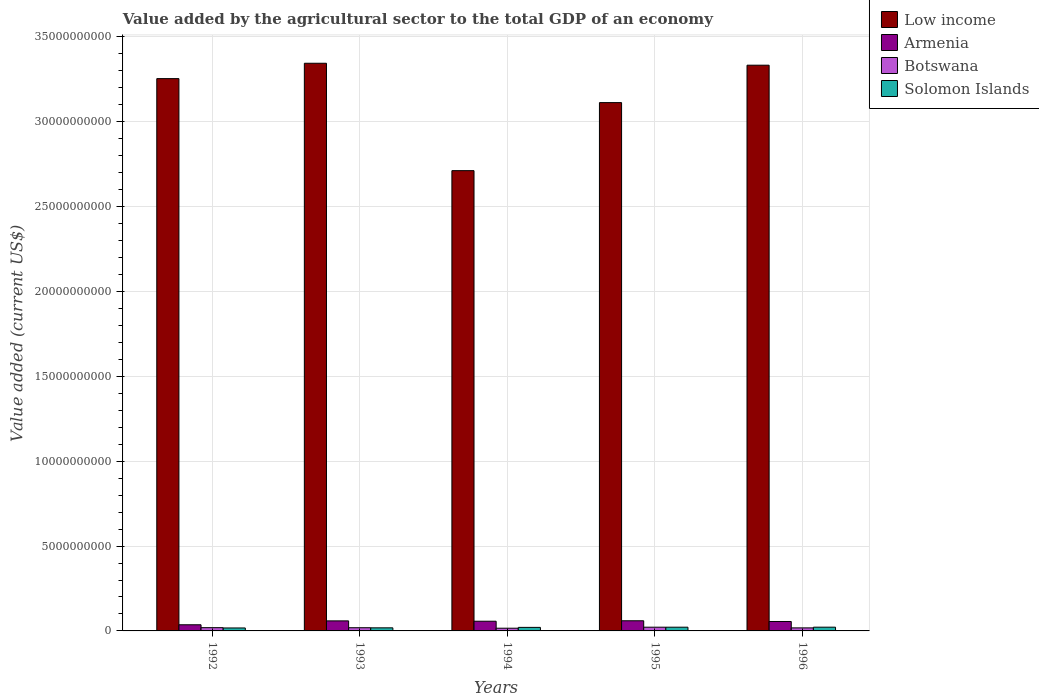How many groups of bars are there?
Make the answer very short. 5. Are the number of bars on each tick of the X-axis equal?
Provide a short and direct response. Yes. What is the label of the 3rd group of bars from the left?
Offer a terse response. 1994. In how many cases, is the number of bars for a given year not equal to the number of legend labels?
Your response must be concise. 0. What is the value added by the agricultural sector to the total GDP in Armenia in 1993?
Offer a terse response. 5.92e+08. Across all years, what is the maximum value added by the agricultural sector to the total GDP in Armenia?
Provide a short and direct response. 5.97e+08. Across all years, what is the minimum value added by the agricultural sector to the total GDP in Armenia?
Give a very brief answer. 3.63e+08. What is the total value added by the agricultural sector to the total GDP in Low income in the graph?
Provide a succinct answer. 1.58e+11. What is the difference between the value added by the agricultural sector to the total GDP in Armenia in 1992 and that in 1996?
Give a very brief answer. -1.93e+08. What is the difference between the value added by the agricultural sector to the total GDP in Solomon Islands in 1992 and the value added by the agricultural sector to the total GDP in Armenia in 1996?
Provide a short and direct response. -3.82e+08. What is the average value added by the agricultural sector to the total GDP in Low income per year?
Provide a succinct answer. 3.15e+1. In the year 1996, what is the difference between the value added by the agricultural sector to the total GDP in Botswana and value added by the agricultural sector to the total GDP in Armenia?
Provide a succinct answer. -3.77e+08. What is the ratio of the value added by the agricultural sector to the total GDP in Low income in 1995 to that in 1996?
Give a very brief answer. 0.93. What is the difference between the highest and the second highest value added by the agricultural sector to the total GDP in Low income?
Provide a succinct answer. 1.14e+08. What is the difference between the highest and the lowest value added by the agricultural sector to the total GDP in Botswana?
Give a very brief answer. 5.94e+07. Is the sum of the value added by the agricultural sector to the total GDP in Low income in 1992 and 1996 greater than the maximum value added by the agricultural sector to the total GDP in Armenia across all years?
Offer a terse response. Yes. What does the 2nd bar from the left in 1994 represents?
Provide a short and direct response. Armenia. What does the 1st bar from the right in 1994 represents?
Ensure brevity in your answer.  Solomon Islands. Are all the bars in the graph horizontal?
Your answer should be compact. No. How many years are there in the graph?
Provide a short and direct response. 5. What is the difference between two consecutive major ticks on the Y-axis?
Offer a terse response. 5.00e+09. Are the values on the major ticks of Y-axis written in scientific E-notation?
Your answer should be very brief. No. How many legend labels are there?
Ensure brevity in your answer.  4. What is the title of the graph?
Make the answer very short. Value added by the agricultural sector to the total GDP of an economy. Does "Honduras" appear as one of the legend labels in the graph?
Make the answer very short. No. What is the label or title of the X-axis?
Keep it short and to the point. Years. What is the label or title of the Y-axis?
Make the answer very short. Value added (current US$). What is the Value added (current US$) of Low income in 1992?
Offer a very short reply. 3.25e+1. What is the Value added (current US$) in Armenia in 1992?
Your answer should be compact. 3.63e+08. What is the Value added (current US$) in Botswana in 1992?
Provide a short and direct response. 1.92e+08. What is the Value added (current US$) of Solomon Islands in 1992?
Provide a succinct answer. 1.74e+08. What is the Value added (current US$) in Low income in 1993?
Make the answer very short. 3.34e+1. What is the Value added (current US$) of Armenia in 1993?
Ensure brevity in your answer.  5.92e+08. What is the Value added (current US$) in Botswana in 1993?
Offer a very short reply. 1.88e+08. What is the Value added (current US$) in Solomon Islands in 1993?
Make the answer very short. 1.82e+08. What is the Value added (current US$) of Low income in 1994?
Provide a short and direct response. 2.71e+1. What is the Value added (current US$) of Armenia in 1994?
Your answer should be very brief. 5.72e+08. What is the Value added (current US$) in Botswana in 1994?
Your response must be concise. 1.60e+08. What is the Value added (current US$) of Solomon Islands in 1994?
Keep it short and to the point. 2.09e+08. What is the Value added (current US$) in Low income in 1995?
Keep it short and to the point. 3.11e+1. What is the Value added (current US$) in Armenia in 1995?
Offer a terse response. 5.97e+08. What is the Value added (current US$) of Botswana in 1995?
Offer a very short reply. 2.19e+08. What is the Value added (current US$) in Solomon Islands in 1995?
Your response must be concise. 2.20e+08. What is the Value added (current US$) in Low income in 1996?
Provide a short and direct response. 3.33e+1. What is the Value added (current US$) of Armenia in 1996?
Offer a terse response. 5.56e+08. What is the Value added (current US$) in Botswana in 1996?
Give a very brief answer. 1.79e+08. What is the Value added (current US$) of Solomon Islands in 1996?
Your response must be concise. 2.21e+08. Across all years, what is the maximum Value added (current US$) of Low income?
Give a very brief answer. 3.34e+1. Across all years, what is the maximum Value added (current US$) in Armenia?
Ensure brevity in your answer.  5.97e+08. Across all years, what is the maximum Value added (current US$) in Botswana?
Your answer should be very brief. 2.19e+08. Across all years, what is the maximum Value added (current US$) of Solomon Islands?
Make the answer very short. 2.21e+08. Across all years, what is the minimum Value added (current US$) in Low income?
Offer a very short reply. 2.71e+1. Across all years, what is the minimum Value added (current US$) in Armenia?
Ensure brevity in your answer.  3.63e+08. Across all years, what is the minimum Value added (current US$) in Botswana?
Your answer should be compact. 1.60e+08. Across all years, what is the minimum Value added (current US$) in Solomon Islands?
Provide a short and direct response. 1.74e+08. What is the total Value added (current US$) of Low income in the graph?
Offer a terse response. 1.58e+11. What is the total Value added (current US$) of Armenia in the graph?
Offer a terse response. 2.68e+09. What is the total Value added (current US$) in Botswana in the graph?
Ensure brevity in your answer.  9.38e+08. What is the total Value added (current US$) of Solomon Islands in the graph?
Give a very brief answer. 1.01e+09. What is the difference between the Value added (current US$) of Low income in 1992 and that in 1993?
Provide a short and direct response. -9.05e+08. What is the difference between the Value added (current US$) in Armenia in 1992 and that in 1993?
Make the answer very short. -2.29e+08. What is the difference between the Value added (current US$) in Botswana in 1992 and that in 1993?
Provide a short and direct response. 4.01e+06. What is the difference between the Value added (current US$) of Solomon Islands in 1992 and that in 1993?
Ensure brevity in your answer.  -8.02e+06. What is the difference between the Value added (current US$) of Low income in 1992 and that in 1994?
Your response must be concise. 5.42e+09. What is the difference between the Value added (current US$) of Armenia in 1992 and that in 1994?
Keep it short and to the point. -2.09e+08. What is the difference between the Value added (current US$) of Botswana in 1992 and that in 1994?
Your answer should be very brief. 3.21e+07. What is the difference between the Value added (current US$) of Solomon Islands in 1992 and that in 1994?
Your answer should be compact. -3.46e+07. What is the difference between the Value added (current US$) of Low income in 1992 and that in 1995?
Give a very brief answer. 1.41e+09. What is the difference between the Value added (current US$) of Armenia in 1992 and that in 1995?
Make the answer very short. -2.35e+08. What is the difference between the Value added (current US$) of Botswana in 1992 and that in 1995?
Give a very brief answer. -2.73e+07. What is the difference between the Value added (current US$) of Solomon Islands in 1992 and that in 1995?
Keep it short and to the point. -4.56e+07. What is the difference between the Value added (current US$) of Low income in 1992 and that in 1996?
Give a very brief answer. -7.91e+08. What is the difference between the Value added (current US$) of Armenia in 1992 and that in 1996?
Ensure brevity in your answer.  -1.93e+08. What is the difference between the Value added (current US$) in Botswana in 1992 and that in 1996?
Your answer should be compact. 1.32e+07. What is the difference between the Value added (current US$) in Solomon Islands in 1992 and that in 1996?
Give a very brief answer. -4.69e+07. What is the difference between the Value added (current US$) in Low income in 1993 and that in 1994?
Your answer should be compact. 6.33e+09. What is the difference between the Value added (current US$) in Armenia in 1993 and that in 1994?
Your answer should be compact. 2.01e+07. What is the difference between the Value added (current US$) of Botswana in 1993 and that in 1994?
Your response must be concise. 2.81e+07. What is the difference between the Value added (current US$) in Solomon Islands in 1993 and that in 1994?
Your answer should be compact. -2.66e+07. What is the difference between the Value added (current US$) of Low income in 1993 and that in 1995?
Your answer should be very brief. 2.32e+09. What is the difference between the Value added (current US$) of Armenia in 1993 and that in 1995?
Make the answer very short. -5.75e+06. What is the difference between the Value added (current US$) in Botswana in 1993 and that in 1995?
Make the answer very short. -3.13e+07. What is the difference between the Value added (current US$) in Solomon Islands in 1993 and that in 1995?
Make the answer very short. -3.76e+07. What is the difference between the Value added (current US$) of Low income in 1993 and that in 1996?
Your response must be concise. 1.14e+08. What is the difference between the Value added (current US$) in Armenia in 1993 and that in 1996?
Ensure brevity in your answer.  3.60e+07. What is the difference between the Value added (current US$) of Botswana in 1993 and that in 1996?
Provide a short and direct response. 9.16e+06. What is the difference between the Value added (current US$) in Solomon Islands in 1993 and that in 1996?
Offer a terse response. -3.89e+07. What is the difference between the Value added (current US$) in Low income in 1994 and that in 1995?
Offer a very short reply. -4.01e+09. What is the difference between the Value added (current US$) of Armenia in 1994 and that in 1995?
Provide a short and direct response. -2.59e+07. What is the difference between the Value added (current US$) of Botswana in 1994 and that in 1995?
Offer a very short reply. -5.94e+07. What is the difference between the Value added (current US$) in Solomon Islands in 1994 and that in 1995?
Keep it short and to the point. -1.10e+07. What is the difference between the Value added (current US$) of Low income in 1994 and that in 1996?
Give a very brief answer. -6.21e+09. What is the difference between the Value added (current US$) of Armenia in 1994 and that in 1996?
Offer a terse response. 1.59e+07. What is the difference between the Value added (current US$) of Botswana in 1994 and that in 1996?
Keep it short and to the point. -1.89e+07. What is the difference between the Value added (current US$) in Solomon Islands in 1994 and that in 1996?
Give a very brief answer. -1.22e+07. What is the difference between the Value added (current US$) of Low income in 1995 and that in 1996?
Your answer should be compact. -2.20e+09. What is the difference between the Value added (current US$) in Armenia in 1995 and that in 1996?
Ensure brevity in your answer.  4.18e+07. What is the difference between the Value added (current US$) of Botswana in 1995 and that in 1996?
Make the answer very short. 4.05e+07. What is the difference between the Value added (current US$) in Solomon Islands in 1995 and that in 1996?
Your answer should be compact. -1.28e+06. What is the difference between the Value added (current US$) in Low income in 1992 and the Value added (current US$) in Armenia in 1993?
Keep it short and to the point. 3.19e+1. What is the difference between the Value added (current US$) of Low income in 1992 and the Value added (current US$) of Botswana in 1993?
Your answer should be compact. 3.24e+1. What is the difference between the Value added (current US$) in Low income in 1992 and the Value added (current US$) in Solomon Islands in 1993?
Offer a terse response. 3.24e+1. What is the difference between the Value added (current US$) in Armenia in 1992 and the Value added (current US$) in Botswana in 1993?
Keep it short and to the point. 1.74e+08. What is the difference between the Value added (current US$) of Armenia in 1992 and the Value added (current US$) of Solomon Islands in 1993?
Make the answer very short. 1.80e+08. What is the difference between the Value added (current US$) of Botswana in 1992 and the Value added (current US$) of Solomon Islands in 1993?
Provide a succinct answer. 1.01e+07. What is the difference between the Value added (current US$) in Low income in 1992 and the Value added (current US$) in Armenia in 1994?
Give a very brief answer. 3.20e+1. What is the difference between the Value added (current US$) of Low income in 1992 and the Value added (current US$) of Botswana in 1994?
Provide a short and direct response. 3.24e+1. What is the difference between the Value added (current US$) in Low income in 1992 and the Value added (current US$) in Solomon Islands in 1994?
Provide a short and direct response. 3.23e+1. What is the difference between the Value added (current US$) of Armenia in 1992 and the Value added (current US$) of Botswana in 1994?
Offer a terse response. 2.03e+08. What is the difference between the Value added (current US$) in Armenia in 1992 and the Value added (current US$) in Solomon Islands in 1994?
Keep it short and to the point. 1.54e+08. What is the difference between the Value added (current US$) of Botswana in 1992 and the Value added (current US$) of Solomon Islands in 1994?
Offer a very short reply. -1.65e+07. What is the difference between the Value added (current US$) of Low income in 1992 and the Value added (current US$) of Armenia in 1995?
Keep it short and to the point. 3.19e+1. What is the difference between the Value added (current US$) of Low income in 1992 and the Value added (current US$) of Botswana in 1995?
Your answer should be compact. 3.23e+1. What is the difference between the Value added (current US$) in Low income in 1992 and the Value added (current US$) in Solomon Islands in 1995?
Give a very brief answer. 3.23e+1. What is the difference between the Value added (current US$) in Armenia in 1992 and the Value added (current US$) in Botswana in 1995?
Your response must be concise. 1.43e+08. What is the difference between the Value added (current US$) of Armenia in 1992 and the Value added (current US$) of Solomon Islands in 1995?
Offer a very short reply. 1.43e+08. What is the difference between the Value added (current US$) of Botswana in 1992 and the Value added (current US$) of Solomon Islands in 1995?
Ensure brevity in your answer.  -2.75e+07. What is the difference between the Value added (current US$) of Low income in 1992 and the Value added (current US$) of Armenia in 1996?
Your answer should be very brief. 3.20e+1. What is the difference between the Value added (current US$) in Low income in 1992 and the Value added (current US$) in Botswana in 1996?
Your answer should be compact. 3.24e+1. What is the difference between the Value added (current US$) of Low income in 1992 and the Value added (current US$) of Solomon Islands in 1996?
Ensure brevity in your answer.  3.23e+1. What is the difference between the Value added (current US$) in Armenia in 1992 and the Value added (current US$) in Botswana in 1996?
Keep it short and to the point. 1.84e+08. What is the difference between the Value added (current US$) of Armenia in 1992 and the Value added (current US$) of Solomon Islands in 1996?
Provide a succinct answer. 1.42e+08. What is the difference between the Value added (current US$) of Botswana in 1992 and the Value added (current US$) of Solomon Islands in 1996?
Provide a succinct answer. -2.88e+07. What is the difference between the Value added (current US$) in Low income in 1993 and the Value added (current US$) in Armenia in 1994?
Ensure brevity in your answer.  3.29e+1. What is the difference between the Value added (current US$) of Low income in 1993 and the Value added (current US$) of Botswana in 1994?
Make the answer very short. 3.33e+1. What is the difference between the Value added (current US$) of Low income in 1993 and the Value added (current US$) of Solomon Islands in 1994?
Provide a succinct answer. 3.32e+1. What is the difference between the Value added (current US$) of Armenia in 1993 and the Value added (current US$) of Botswana in 1994?
Give a very brief answer. 4.32e+08. What is the difference between the Value added (current US$) in Armenia in 1993 and the Value added (current US$) in Solomon Islands in 1994?
Give a very brief answer. 3.83e+08. What is the difference between the Value added (current US$) of Botswana in 1993 and the Value added (current US$) of Solomon Islands in 1994?
Your answer should be very brief. -2.05e+07. What is the difference between the Value added (current US$) of Low income in 1993 and the Value added (current US$) of Armenia in 1995?
Offer a terse response. 3.28e+1. What is the difference between the Value added (current US$) in Low income in 1993 and the Value added (current US$) in Botswana in 1995?
Provide a short and direct response. 3.32e+1. What is the difference between the Value added (current US$) of Low income in 1993 and the Value added (current US$) of Solomon Islands in 1995?
Provide a succinct answer. 3.32e+1. What is the difference between the Value added (current US$) of Armenia in 1993 and the Value added (current US$) of Botswana in 1995?
Your answer should be compact. 3.72e+08. What is the difference between the Value added (current US$) of Armenia in 1993 and the Value added (current US$) of Solomon Islands in 1995?
Give a very brief answer. 3.72e+08. What is the difference between the Value added (current US$) of Botswana in 1993 and the Value added (current US$) of Solomon Islands in 1995?
Your answer should be compact. -3.15e+07. What is the difference between the Value added (current US$) of Low income in 1993 and the Value added (current US$) of Armenia in 1996?
Provide a succinct answer. 3.29e+1. What is the difference between the Value added (current US$) in Low income in 1993 and the Value added (current US$) in Botswana in 1996?
Ensure brevity in your answer.  3.33e+1. What is the difference between the Value added (current US$) in Low income in 1993 and the Value added (current US$) in Solomon Islands in 1996?
Ensure brevity in your answer.  3.32e+1. What is the difference between the Value added (current US$) of Armenia in 1993 and the Value added (current US$) of Botswana in 1996?
Ensure brevity in your answer.  4.13e+08. What is the difference between the Value added (current US$) in Armenia in 1993 and the Value added (current US$) in Solomon Islands in 1996?
Ensure brevity in your answer.  3.71e+08. What is the difference between the Value added (current US$) of Botswana in 1993 and the Value added (current US$) of Solomon Islands in 1996?
Keep it short and to the point. -3.28e+07. What is the difference between the Value added (current US$) in Low income in 1994 and the Value added (current US$) in Armenia in 1995?
Your answer should be compact. 2.65e+1. What is the difference between the Value added (current US$) in Low income in 1994 and the Value added (current US$) in Botswana in 1995?
Give a very brief answer. 2.69e+1. What is the difference between the Value added (current US$) in Low income in 1994 and the Value added (current US$) in Solomon Islands in 1995?
Ensure brevity in your answer.  2.69e+1. What is the difference between the Value added (current US$) of Armenia in 1994 and the Value added (current US$) of Botswana in 1995?
Make the answer very short. 3.52e+08. What is the difference between the Value added (current US$) of Armenia in 1994 and the Value added (current US$) of Solomon Islands in 1995?
Give a very brief answer. 3.52e+08. What is the difference between the Value added (current US$) of Botswana in 1994 and the Value added (current US$) of Solomon Islands in 1995?
Ensure brevity in your answer.  -5.96e+07. What is the difference between the Value added (current US$) in Low income in 1994 and the Value added (current US$) in Armenia in 1996?
Make the answer very short. 2.66e+1. What is the difference between the Value added (current US$) of Low income in 1994 and the Value added (current US$) of Botswana in 1996?
Provide a short and direct response. 2.69e+1. What is the difference between the Value added (current US$) of Low income in 1994 and the Value added (current US$) of Solomon Islands in 1996?
Make the answer very short. 2.69e+1. What is the difference between the Value added (current US$) of Armenia in 1994 and the Value added (current US$) of Botswana in 1996?
Your answer should be compact. 3.93e+08. What is the difference between the Value added (current US$) of Armenia in 1994 and the Value added (current US$) of Solomon Islands in 1996?
Provide a short and direct response. 3.51e+08. What is the difference between the Value added (current US$) in Botswana in 1994 and the Value added (current US$) in Solomon Islands in 1996?
Your response must be concise. -6.09e+07. What is the difference between the Value added (current US$) in Low income in 1995 and the Value added (current US$) in Armenia in 1996?
Provide a short and direct response. 3.06e+1. What is the difference between the Value added (current US$) in Low income in 1995 and the Value added (current US$) in Botswana in 1996?
Your answer should be compact. 3.09e+1. What is the difference between the Value added (current US$) in Low income in 1995 and the Value added (current US$) in Solomon Islands in 1996?
Give a very brief answer. 3.09e+1. What is the difference between the Value added (current US$) in Armenia in 1995 and the Value added (current US$) in Botswana in 1996?
Offer a very short reply. 4.19e+08. What is the difference between the Value added (current US$) of Armenia in 1995 and the Value added (current US$) of Solomon Islands in 1996?
Your response must be concise. 3.77e+08. What is the difference between the Value added (current US$) of Botswana in 1995 and the Value added (current US$) of Solomon Islands in 1996?
Your response must be concise. -1.47e+06. What is the average Value added (current US$) of Low income per year?
Offer a terse response. 3.15e+1. What is the average Value added (current US$) of Armenia per year?
Keep it short and to the point. 5.36e+08. What is the average Value added (current US$) of Botswana per year?
Provide a succinct answer. 1.88e+08. What is the average Value added (current US$) of Solomon Islands per year?
Give a very brief answer. 2.01e+08. In the year 1992, what is the difference between the Value added (current US$) in Low income and Value added (current US$) in Armenia?
Provide a short and direct response. 3.22e+1. In the year 1992, what is the difference between the Value added (current US$) in Low income and Value added (current US$) in Botswana?
Ensure brevity in your answer.  3.23e+1. In the year 1992, what is the difference between the Value added (current US$) of Low income and Value added (current US$) of Solomon Islands?
Ensure brevity in your answer.  3.24e+1. In the year 1992, what is the difference between the Value added (current US$) in Armenia and Value added (current US$) in Botswana?
Provide a short and direct response. 1.70e+08. In the year 1992, what is the difference between the Value added (current US$) of Armenia and Value added (current US$) of Solomon Islands?
Give a very brief answer. 1.89e+08. In the year 1992, what is the difference between the Value added (current US$) in Botswana and Value added (current US$) in Solomon Islands?
Your response must be concise. 1.81e+07. In the year 1993, what is the difference between the Value added (current US$) of Low income and Value added (current US$) of Armenia?
Your answer should be compact. 3.29e+1. In the year 1993, what is the difference between the Value added (current US$) of Low income and Value added (current US$) of Botswana?
Provide a succinct answer. 3.33e+1. In the year 1993, what is the difference between the Value added (current US$) of Low income and Value added (current US$) of Solomon Islands?
Make the answer very short. 3.33e+1. In the year 1993, what is the difference between the Value added (current US$) in Armenia and Value added (current US$) in Botswana?
Your answer should be compact. 4.04e+08. In the year 1993, what is the difference between the Value added (current US$) in Armenia and Value added (current US$) in Solomon Islands?
Keep it short and to the point. 4.10e+08. In the year 1993, what is the difference between the Value added (current US$) in Botswana and Value added (current US$) in Solomon Islands?
Make the answer very short. 6.07e+06. In the year 1994, what is the difference between the Value added (current US$) in Low income and Value added (current US$) in Armenia?
Your response must be concise. 2.65e+1. In the year 1994, what is the difference between the Value added (current US$) in Low income and Value added (current US$) in Botswana?
Offer a very short reply. 2.70e+1. In the year 1994, what is the difference between the Value added (current US$) in Low income and Value added (current US$) in Solomon Islands?
Ensure brevity in your answer.  2.69e+1. In the year 1994, what is the difference between the Value added (current US$) in Armenia and Value added (current US$) in Botswana?
Provide a short and direct response. 4.12e+08. In the year 1994, what is the difference between the Value added (current US$) of Armenia and Value added (current US$) of Solomon Islands?
Ensure brevity in your answer.  3.63e+08. In the year 1994, what is the difference between the Value added (current US$) of Botswana and Value added (current US$) of Solomon Islands?
Offer a very short reply. -4.86e+07. In the year 1995, what is the difference between the Value added (current US$) in Low income and Value added (current US$) in Armenia?
Your response must be concise. 3.05e+1. In the year 1995, what is the difference between the Value added (current US$) in Low income and Value added (current US$) in Botswana?
Ensure brevity in your answer.  3.09e+1. In the year 1995, what is the difference between the Value added (current US$) of Low income and Value added (current US$) of Solomon Islands?
Your answer should be very brief. 3.09e+1. In the year 1995, what is the difference between the Value added (current US$) of Armenia and Value added (current US$) of Botswana?
Provide a short and direct response. 3.78e+08. In the year 1995, what is the difference between the Value added (current US$) in Armenia and Value added (current US$) in Solomon Islands?
Provide a succinct answer. 3.78e+08. In the year 1995, what is the difference between the Value added (current US$) of Botswana and Value added (current US$) of Solomon Islands?
Provide a short and direct response. -1.97e+05. In the year 1996, what is the difference between the Value added (current US$) in Low income and Value added (current US$) in Armenia?
Your response must be concise. 3.28e+1. In the year 1996, what is the difference between the Value added (current US$) in Low income and Value added (current US$) in Botswana?
Ensure brevity in your answer.  3.32e+1. In the year 1996, what is the difference between the Value added (current US$) of Low income and Value added (current US$) of Solomon Islands?
Ensure brevity in your answer.  3.31e+1. In the year 1996, what is the difference between the Value added (current US$) in Armenia and Value added (current US$) in Botswana?
Your answer should be compact. 3.77e+08. In the year 1996, what is the difference between the Value added (current US$) of Armenia and Value added (current US$) of Solomon Islands?
Keep it short and to the point. 3.35e+08. In the year 1996, what is the difference between the Value added (current US$) of Botswana and Value added (current US$) of Solomon Islands?
Your answer should be compact. -4.19e+07. What is the ratio of the Value added (current US$) in Low income in 1992 to that in 1993?
Offer a terse response. 0.97. What is the ratio of the Value added (current US$) in Armenia in 1992 to that in 1993?
Your answer should be very brief. 0.61. What is the ratio of the Value added (current US$) in Botswana in 1992 to that in 1993?
Provide a short and direct response. 1.02. What is the ratio of the Value added (current US$) of Solomon Islands in 1992 to that in 1993?
Keep it short and to the point. 0.96. What is the ratio of the Value added (current US$) in Low income in 1992 to that in 1994?
Your answer should be very brief. 1.2. What is the ratio of the Value added (current US$) of Armenia in 1992 to that in 1994?
Make the answer very short. 0.63. What is the ratio of the Value added (current US$) in Botswana in 1992 to that in 1994?
Your response must be concise. 1.2. What is the ratio of the Value added (current US$) in Solomon Islands in 1992 to that in 1994?
Your response must be concise. 0.83. What is the ratio of the Value added (current US$) in Low income in 1992 to that in 1995?
Your response must be concise. 1.05. What is the ratio of the Value added (current US$) of Armenia in 1992 to that in 1995?
Provide a succinct answer. 0.61. What is the ratio of the Value added (current US$) of Botswana in 1992 to that in 1995?
Your response must be concise. 0.88. What is the ratio of the Value added (current US$) in Solomon Islands in 1992 to that in 1995?
Provide a succinct answer. 0.79. What is the ratio of the Value added (current US$) of Low income in 1992 to that in 1996?
Offer a terse response. 0.98. What is the ratio of the Value added (current US$) of Armenia in 1992 to that in 1996?
Your answer should be very brief. 0.65. What is the ratio of the Value added (current US$) in Botswana in 1992 to that in 1996?
Your answer should be compact. 1.07. What is the ratio of the Value added (current US$) in Solomon Islands in 1992 to that in 1996?
Offer a very short reply. 0.79. What is the ratio of the Value added (current US$) of Low income in 1993 to that in 1994?
Provide a succinct answer. 1.23. What is the ratio of the Value added (current US$) of Armenia in 1993 to that in 1994?
Provide a short and direct response. 1.04. What is the ratio of the Value added (current US$) in Botswana in 1993 to that in 1994?
Offer a very short reply. 1.18. What is the ratio of the Value added (current US$) in Solomon Islands in 1993 to that in 1994?
Offer a terse response. 0.87. What is the ratio of the Value added (current US$) of Low income in 1993 to that in 1995?
Provide a succinct answer. 1.07. What is the ratio of the Value added (current US$) in Botswana in 1993 to that in 1995?
Make the answer very short. 0.86. What is the ratio of the Value added (current US$) in Solomon Islands in 1993 to that in 1995?
Your answer should be compact. 0.83. What is the ratio of the Value added (current US$) of Armenia in 1993 to that in 1996?
Your answer should be very brief. 1.06. What is the ratio of the Value added (current US$) of Botswana in 1993 to that in 1996?
Your answer should be compact. 1.05. What is the ratio of the Value added (current US$) in Solomon Islands in 1993 to that in 1996?
Offer a very short reply. 0.82. What is the ratio of the Value added (current US$) in Low income in 1994 to that in 1995?
Make the answer very short. 0.87. What is the ratio of the Value added (current US$) of Armenia in 1994 to that in 1995?
Provide a succinct answer. 0.96. What is the ratio of the Value added (current US$) in Botswana in 1994 to that in 1995?
Offer a very short reply. 0.73. What is the ratio of the Value added (current US$) in Solomon Islands in 1994 to that in 1995?
Your response must be concise. 0.95. What is the ratio of the Value added (current US$) of Low income in 1994 to that in 1996?
Give a very brief answer. 0.81. What is the ratio of the Value added (current US$) in Armenia in 1994 to that in 1996?
Keep it short and to the point. 1.03. What is the ratio of the Value added (current US$) of Botswana in 1994 to that in 1996?
Provide a short and direct response. 0.89. What is the ratio of the Value added (current US$) of Solomon Islands in 1994 to that in 1996?
Give a very brief answer. 0.94. What is the ratio of the Value added (current US$) of Low income in 1995 to that in 1996?
Your answer should be compact. 0.93. What is the ratio of the Value added (current US$) in Armenia in 1995 to that in 1996?
Give a very brief answer. 1.08. What is the ratio of the Value added (current US$) of Botswana in 1995 to that in 1996?
Provide a succinct answer. 1.23. What is the ratio of the Value added (current US$) in Solomon Islands in 1995 to that in 1996?
Your answer should be compact. 0.99. What is the difference between the highest and the second highest Value added (current US$) in Low income?
Keep it short and to the point. 1.14e+08. What is the difference between the highest and the second highest Value added (current US$) in Armenia?
Offer a terse response. 5.75e+06. What is the difference between the highest and the second highest Value added (current US$) in Botswana?
Offer a terse response. 2.73e+07. What is the difference between the highest and the second highest Value added (current US$) of Solomon Islands?
Provide a succinct answer. 1.28e+06. What is the difference between the highest and the lowest Value added (current US$) in Low income?
Provide a succinct answer. 6.33e+09. What is the difference between the highest and the lowest Value added (current US$) of Armenia?
Provide a succinct answer. 2.35e+08. What is the difference between the highest and the lowest Value added (current US$) in Botswana?
Offer a very short reply. 5.94e+07. What is the difference between the highest and the lowest Value added (current US$) in Solomon Islands?
Make the answer very short. 4.69e+07. 